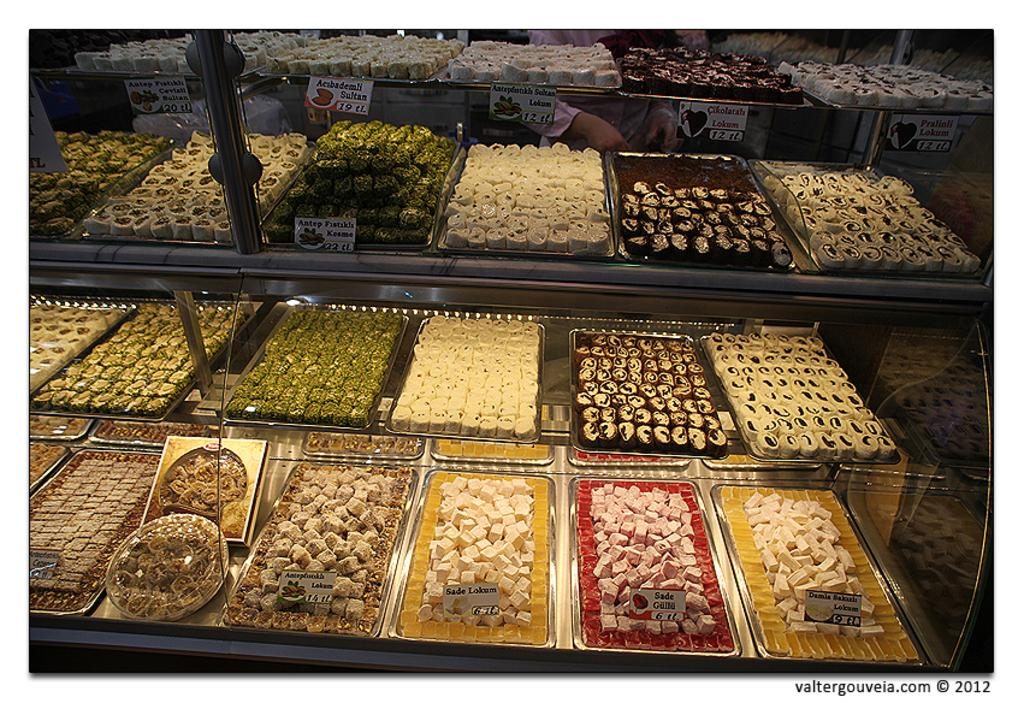What type of food can be seen in the image? There are sweets in the image. How are the sweets organized or displayed? The sweets are arranged in trays. What type of alarm can be heard going off in the image? There is no alarm present in the image, as it only features sweets arranged in trays. 